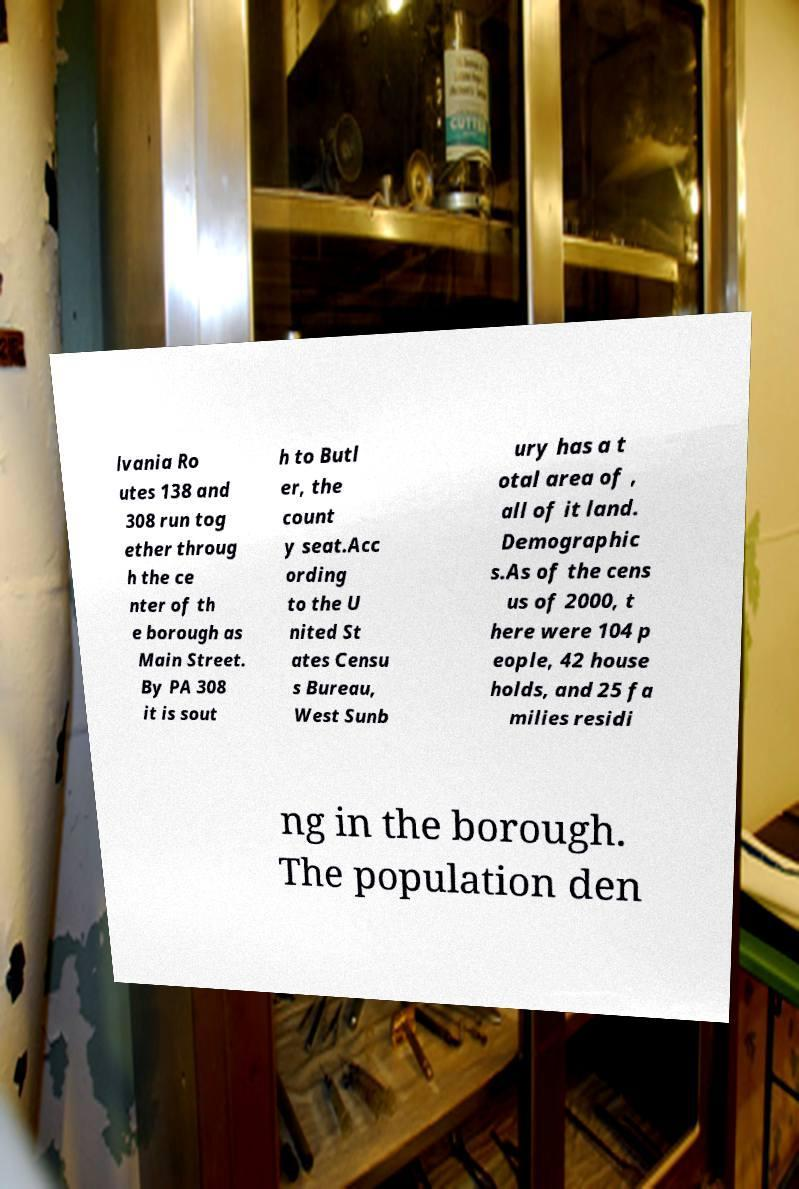Could you assist in decoding the text presented in this image and type it out clearly? lvania Ro utes 138 and 308 run tog ether throug h the ce nter of th e borough as Main Street. By PA 308 it is sout h to Butl er, the count y seat.Acc ording to the U nited St ates Censu s Bureau, West Sunb ury has a t otal area of , all of it land. Demographic s.As of the cens us of 2000, t here were 104 p eople, 42 house holds, and 25 fa milies residi ng in the borough. The population den 